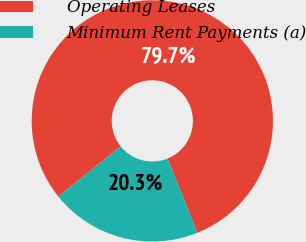<chart> <loc_0><loc_0><loc_500><loc_500><pie_chart><fcel>Operating Leases<fcel>Minimum Rent Payments (a)<nl><fcel>79.68%<fcel>20.32%<nl></chart> 